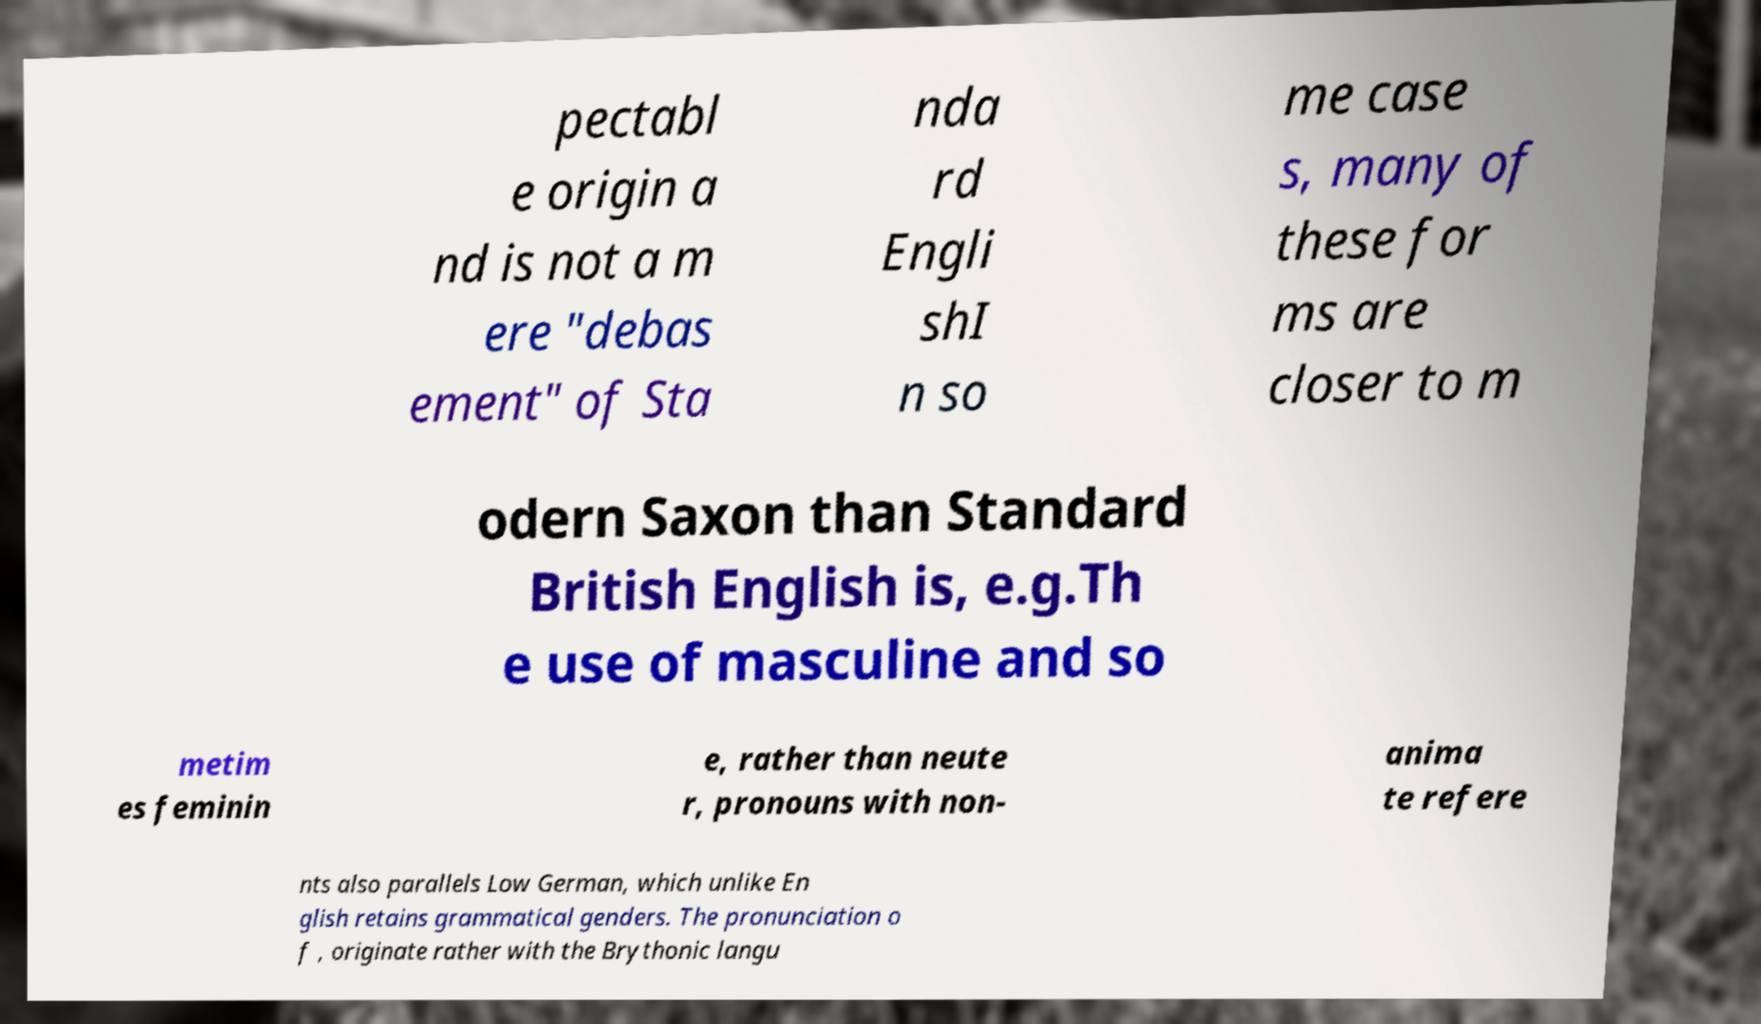What messages or text are displayed in this image? I need them in a readable, typed format. pectabl e origin a nd is not a m ere "debas ement" of Sta nda rd Engli shI n so me case s, many of these for ms are closer to m odern Saxon than Standard British English is, e.g.Th e use of masculine and so metim es feminin e, rather than neute r, pronouns with non- anima te refere nts also parallels Low German, which unlike En glish retains grammatical genders. The pronunciation o f , originate rather with the Brythonic langu 